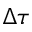<formula> <loc_0><loc_0><loc_500><loc_500>\Delta \tau</formula> 